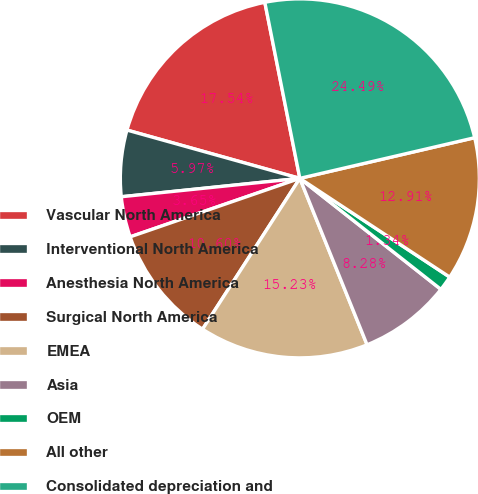<chart> <loc_0><loc_0><loc_500><loc_500><pie_chart><fcel>Vascular North America<fcel>Interventional North America<fcel>Anesthesia North America<fcel>Surgical North America<fcel>EMEA<fcel>Asia<fcel>OEM<fcel>All other<fcel>Consolidated depreciation and<nl><fcel>17.54%<fcel>5.97%<fcel>3.65%<fcel>10.6%<fcel>15.23%<fcel>8.28%<fcel>1.34%<fcel>12.91%<fcel>24.49%<nl></chart> 